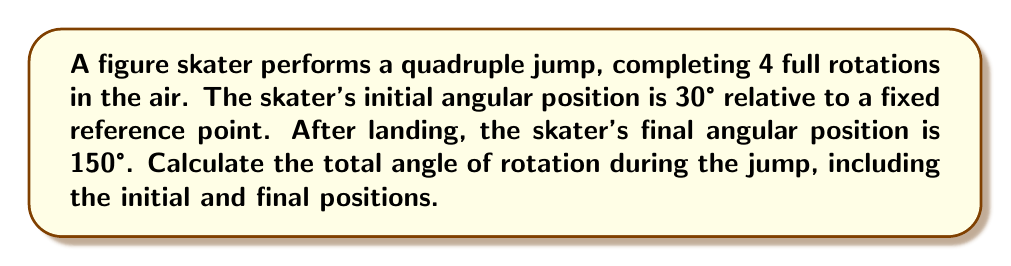Provide a solution to this math problem. To solve this problem, we need to consider the following steps:

1. Calculate the rotation from the full turns:
   $$ \text{Rotation from full turns} = 4 \times 360° = 1440° $$

2. Calculate the additional rotation from the initial to final position:
   $$ \text{Additional rotation} = \text{Final position} - \text{Initial position} $$
   $$ \text{Additional rotation} = 150° - 30° = 120° $$

3. Sum up the total rotation:
   $$ \text{Total rotation} = \text{Rotation from full turns} + \text{Additional rotation} $$
   $$ \text{Total rotation} = 1440° + 120° = 1560° $$

[asy]
import geometry;

size(200);
draw(circle((0,0),1));
draw((0,0)--(cos(radians(30)),sin(radians(30))), arrow=Arrow(TeXHead));
draw((0,0)--(cos(radians(150)),sin(radians(150))), arrow=Arrow(TeXHead));
label("30°", (0.7,0.2));
label("150°", (-0.7,0.2));
draw(arc((0,0),0.7,30,150), arrow=Arrow(TeXHead));
label("120°", (0,0.7));
[/asy]

The diagram illustrates the initial and final positions of the skater, as well as the additional rotation between these positions.
Answer: The total angle of rotation during the jump is 1560°. 